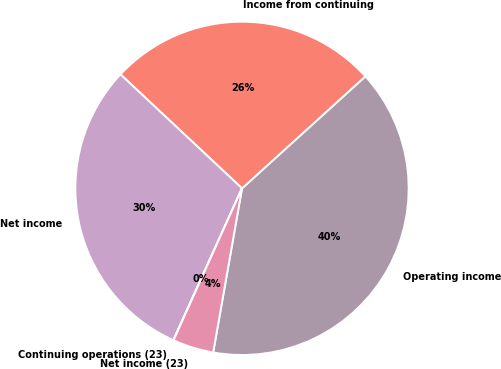<chart> <loc_0><loc_0><loc_500><loc_500><pie_chart><fcel>Operating income<fcel>Income from continuing<fcel>Net income<fcel>Continuing operations (23)<fcel>Net income (23)<nl><fcel>39.5%<fcel>26.28%<fcel>30.23%<fcel>0.02%<fcel>3.97%<nl></chart> 